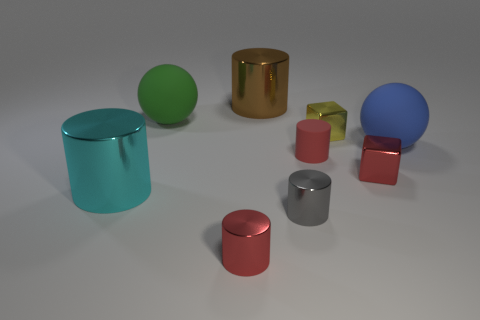What number of other things are there of the same color as the rubber cylinder?
Offer a very short reply. 2. What number of green objects are either big things or small matte objects?
Provide a short and direct response. 1. There is a big object that is to the right of the brown metallic cylinder; what is its material?
Give a very brief answer. Rubber. Does the ball that is to the right of the yellow thing have the same material as the big green sphere?
Provide a short and direct response. Yes. What is the shape of the big cyan metal thing?
Your response must be concise. Cylinder. What number of yellow objects are on the left side of the tiny red shiny cylinder that is right of the big metal cylinder that is in front of the tiny rubber thing?
Your answer should be compact. 0. What number of other things are there of the same material as the gray cylinder
Your response must be concise. 5. There is a yellow block that is the same size as the red shiny block; what is it made of?
Provide a succinct answer. Metal. There is a small cylinder that is behind the cyan cylinder; is it the same color as the cube that is in front of the small yellow block?
Offer a very short reply. Yes. Is there a cyan shiny thing of the same shape as the yellow metallic object?
Make the answer very short. No. 